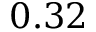<formula> <loc_0><loc_0><loc_500><loc_500>0 . 3 2</formula> 